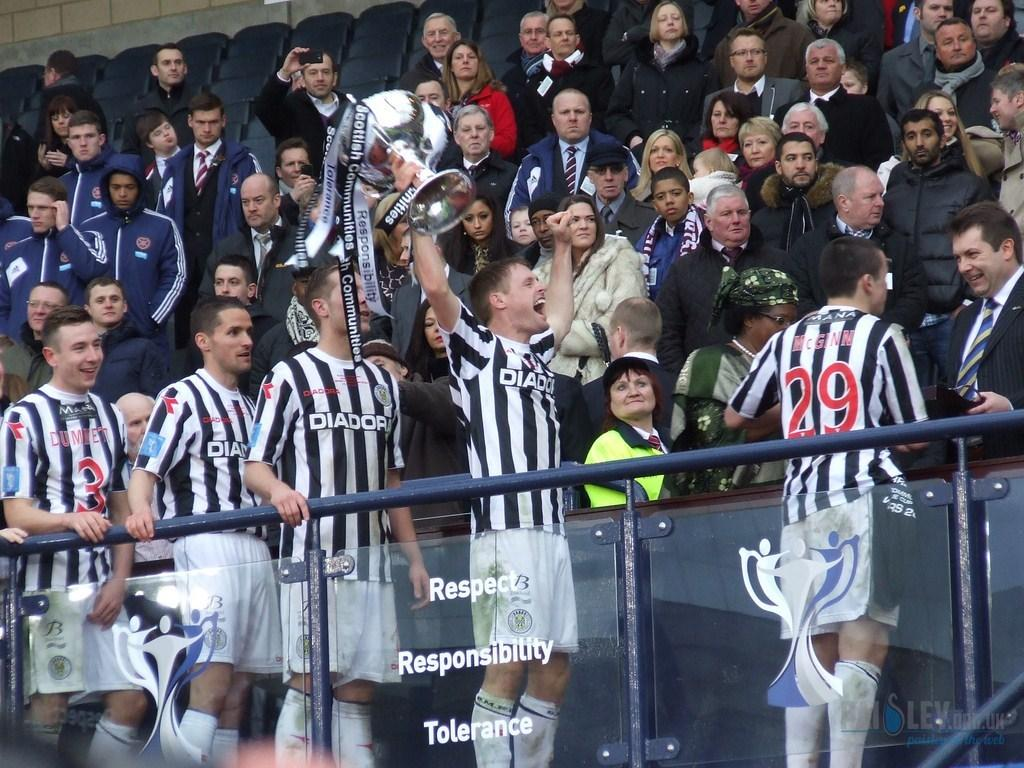<image>
Present a compact description of the photo's key features. Soccor players in the stands with Diadora on their jersey 